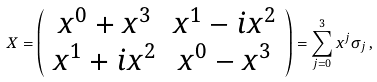Convert formula to latex. <formula><loc_0><loc_0><loc_500><loc_500>X = \left ( \begin{array} { c c } x ^ { 0 } + x ^ { 3 } & x ^ { 1 } - i x ^ { 2 } \\ x ^ { 1 } + i x ^ { 2 } & x ^ { 0 } - x ^ { 3 } \end{array} \right ) = \sum _ { j = 0 } ^ { 3 } x ^ { j } \sigma _ { j } \, ,</formula> 